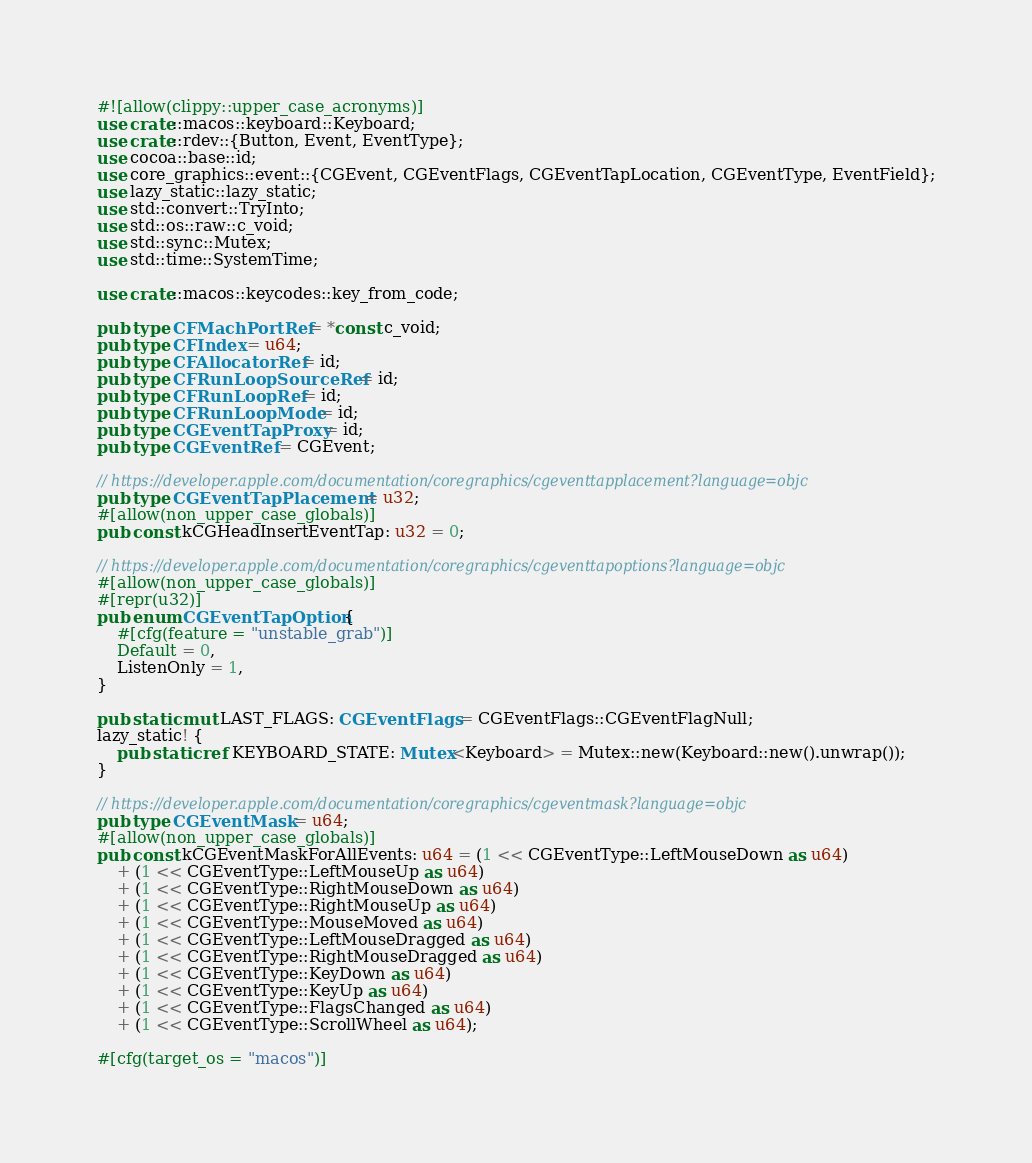Convert code to text. <code><loc_0><loc_0><loc_500><loc_500><_Rust_>#![allow(clippy::upper_case_acronyms)]
use crate::macos::keyboard::Keyboard;
use crate::rdev::{Button, Event, EventType};
use cocoa::base::id;
use core_graphics::event::{CGEvent, CGEventFlags, CGEventTapLocation, CGEventType, EventField};
use lazy_static::lazy_static;
use std::convert::TryInto;
use std::os::raw::c_void;
use std::sync::Mutex;
use std::time::SystemTime;

use crate::macos::keycodes::key_from_code;

pub type CFMachPortRef = *const c_void;
pub type CFIndex = u64;
pub type CFAllocatorRef = id;
pub type CFRunLoopSourceRef = id;
pub type CFRunLoopRef = id;
pub type CFRunLoopMode = id;
pub type CGEventTapProxy = id;
pub type CGEventRef = CGEvent;

// https://developer.apple.com/documentation/coregraphics/cgeventtapplacement?language=objc
pub type CGEventTapPlacement = u32;
#[allow(non_upper_case_globals)]
pub const kCGHeadInsertEventTap: u32 = 0;

// https://developer.apple.com/documentation/coregraphics/cgeventtapoptions?language=objc
#[allow(non_upper_case_globals)]
#[repr(u32)]
pub enum CGEventTapOption {
    #[cfg(feature = "unstable_grab")]
    Default = 0,
    ListenOnly = 1,
}

pub static mut LAST_FLAGS: CGEventFlags = CGEventFlags::CGEventFlagNull;
lazy_static! {
    pub static ref KEYBOARD_STATE: Mutex<Keyboard> = Mutex::new(Keyboard::new().unwrap());
}

// https://developer.apple.com/documentation/coregraphics/cgeventmask?language=objc
pub type CGEventMask = u64;
#[allow(non_upper_case_globals)]
pub const kCGEventMaskForAllEvents: u64 = (1 << CGEventType::LeftMouseDown as u64)
    + (1 << CGEventType::LeftMouseUp as u64)
    + (1 << CGEventType::RightMouseDown as u64)
    + (1 << CGEventType::RightMouseUp as u64)
    + (1 << CGEventType::MouseMoved as u64)
    + (1 << CGEventType::LeftMouseDragged as u64)
    + (1 << CGEventType::RightMouseDragged as u64)
    + (1 << CGEventType::KeyDown as u64)
    + (1 << CGEventType::KeyUp as u64)
    + (1 << CGEventType::FlagsChanged as u64)
    + (1 << CGEventType::ScrollWheel as u64);

#[cfg(target_os = "macos")]</code> 